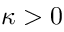Convert formula to latex. <formula><loc_0><loc_0><loc_500><loc_500>\kappa > 0</formula> 